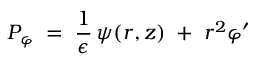<formula> <loc_0><loc_0><loc_500><loc_500>P _ { \varphi } \, = \, \frac { 1 } { \epsilon } \, \psi ( r , z ) \, + \, r ^ { 2 } \varphi ^ { \prime }</formula> 